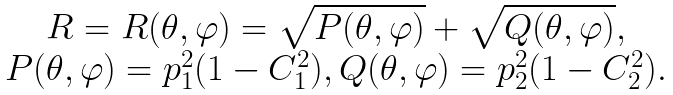Convert formula to latex. <formula><loc_0><loc_0><loc_500><loc_500>\begin{array} { c } R = R ( \theta , \varphi ) = \sqrt { P ( \theta , \varphi ) } + \sqrt { Q ( \theta , \varphi ) } , \\ P ( \theta , \varphi ) = p _ { 1 } ^ { 2 } ( 1 - C _ { 1 } ^ { 2 } ) , Q ( \theta , \varphi ) = p _ { 2 } ^ { 2 } ( 1 - C _ { 2 } ^ { 2 } ) . \end{array}</formula> 